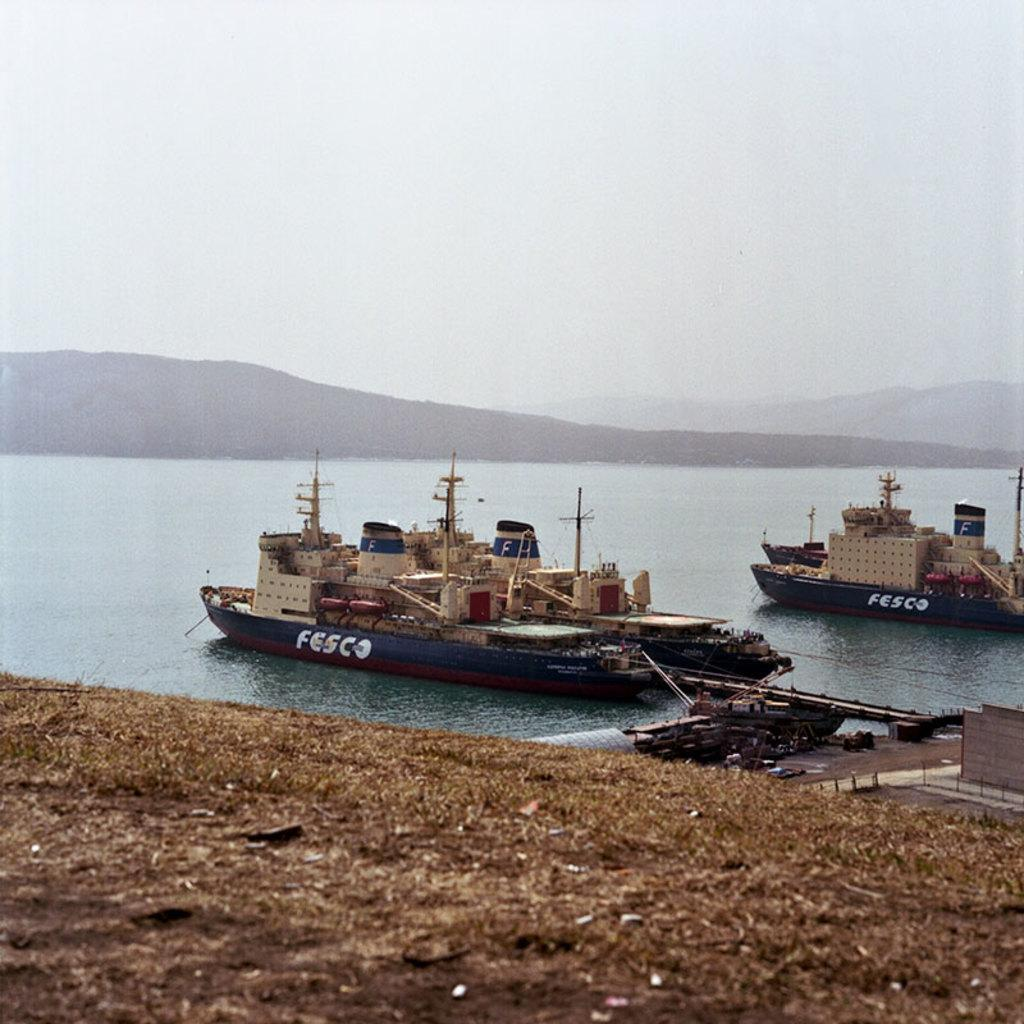Provide a one-sentence caption for the provided image. a fesco boat that is on the water outside. 